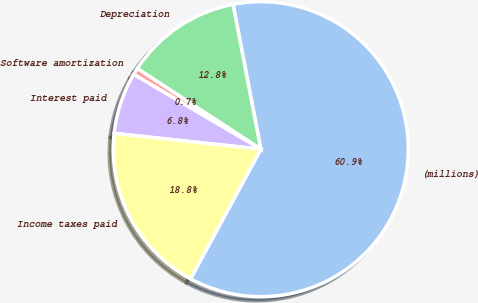<chart> <loc_0><loc_0><loc_500><loc_500><pie_chart><fcel>(millions)<fcel>Depreciation<fcel>Software amortization<fcel>Interest paid<fcel>Income taxes paid<nl><fcel>60.93%<fcel>12.78%<fcel>0.74%<fcel>6.76%<fcel>18.8%<nl></chart> 